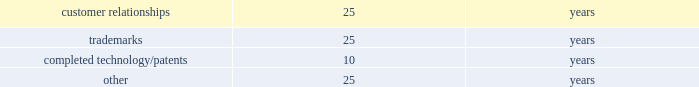Table of contents recoverability of goodwill is measured at the reporting unit level and begins with a qualitative assessment to determine if it is more likely than not that the fair value of each reporting unit is less than its carrying amount as a basis for determining whether it is necessary to perform the two-step goodwill impairment test prescribed by gaap .
For those reporting units where it is required , the first step compares the carrying amount of the reporting unit to its estimated fair value .
If the estimated fair value of a reporting unit exceeds its carrying amount , goodwill of the reporting unit is not impaired and the second step of the impairment test is not necessary .
To the extent that the carrying value of the reporting unit exceeds its estimated fair value , a second step is performed , wherein the reporting unit's carrying value of goodwill is compared to the implied fair value of goodwill .
To the extent that the carrying value exceeds the implied fair value , impairment exists and must be recognized .
The calculation of estimated fair value is based on two valuation techniques , a discounted cash flow model ( income approach ) and a market adjusted multiple of earnings and revenues ( market approach ) , with each method being weighted in the calculation .
The implied fair value of goodwill is determined in the same manner as the amount of goodwill recognized in a business combination .
The estimated fair value of the reporting unit is allocated to all of the assets and liabilities of the reporting unit ( including any unrecognized intangible assets ) as if the reporting unit had been acquired in a business combination and the fair value of the reporting unit , as determined in the first step of the goodwill impairment test , was the price paid to acquire that reporting unit .
Recoverability of other intangible assets with indefinite useful lives ( i.e .
Trademarks ) is determined on a relief from royalty methodology ( income approach ) , which is based on the implied royalty paid , at an appropriate discount rate , to license the use of an asset rather than owning the asset .
The present value of the after-tax cost savings ( i.e .
Royalty relief ) indicates the estimated fair value of the asset .
Any excess of the carrying value over the estimated fair value is recognized as an impairment loss equal to that excess .
Intangible assets such as patents , customer-related intangible assets and other intangible assets with finite useful lives are amortized on a straight-line basis over their estimated economic lives .
The weighted-average useful lives approximate the following: .
Recoverability of intangible assets with finite useful lives is assessed in the same manner as property , plant and equipment as described above .
Income taxes : for purposes of the company 2019s consolidated financial statements for periods prior to the spin-off , income tax expense has been recorded as if the company filed tax returns on a stand-alone basis separate from ingersoll rand .
This separate return methodology applies the accounting guidance for income taxes to the stand-alone financial statements as if the company was a stand-alone enterprise for the periods prior to the spin-off .
Therefore , cash tax payments and items of current and deferred taxes may not be reflective of the company 2019s actual tax balances prior to or subsequent to the spin-off .
Cash paid for income taxes for the year ended december 31 , 2015 was $ 80.6 million .
The income tax accounts reflected in the consolidated balance sheets as of december 31 , 2015 and 2014 include income taxes payable and deferred taxes allocated to the company at the time of the spin-off .
The calculation of the company 2019s income taxes involves considerable judgment and the use of both estimates and allocations .
Deferred tax assets and liabilities are determined based on temporary differences between financial reporting and tax bases of assets and liabilities , applying enacted tax rates expected to be in effect for the year in which the differences are expected to reverse .
The company recognizes future tax benefits , such as net operating losses and tax credits , to the extent that realizing these benefits is considered in its judgment to be more likely than not .
The company regularly reviews the recoverability of its deferred tax assets considering its historic profitability , projected future taxable income , timing of the reversals of existing temporary differences and the feasibility of its tax planning strategies .
Where appropriate , the company records a valuation allowance with respect to a future tax benefit .
Product warranties : standard product warranty accruals are recorded at the time of sale and are estimated based upon product warranty terms and historical experience .
The company assesses the adequacy of its liabilities and will make adjustments as necessary based on known or anticipated warranty claims , or as new information becomes available. .
What is the difference between the weighted average useful lives of trademarks and patents , in number of years?\\n? 
Rationale: it is the variation between those weighted-average useful lives .
Computations: (25 - 10)
Answer: 15.0. 